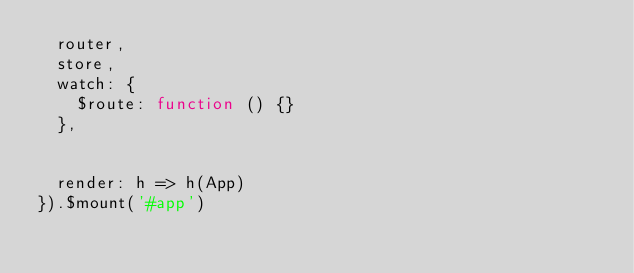Convert code to text. <code><loc_0><loc_0><loc_500><loc_500><_JavaScript_>  router,
  store,
  watch: {
    $route: function () {}
  },


  render: h => h(App)
}).$mount('#app')</code> 